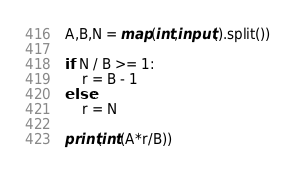Convert code to text. <code><loc_0><loc_0><loc_500><loc_500><_Python_>A,B,N = map(int,input().split())

if N / B >= 1:
    r = B - 1
else:
    r = N

print(int(A*r/B))
</code> 